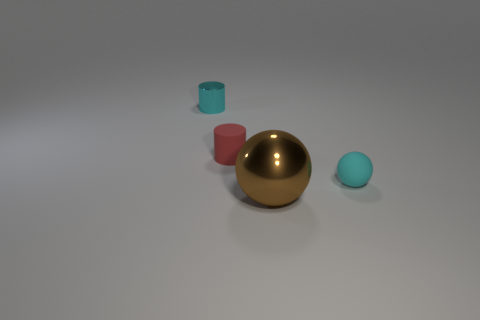There is a object that is the same color as the tiny metal cylinder; what is its material?
Offer a terse response. Rubber. Is the brown object the same size as the cyan metallic object?
Your answer should be very brief. No. There is a cyan object that is in front of the cyan object that is to the left of the rubber object to the right of the big brown metal ball; what is it made of?
Ensure brevity in your answer.  Rubber. Are there an equal number of tiny cyan balls behind the cyan sphere and brown spheres?
Ensure brevity in your answer.  No. Are there any other things that have the same size as the metal cylinder?
Your response must be concise. Yes. How many objects are big brown balls or blue things?
Your answer should be compact. 1. The other thing that is made of the same material as the tiny red thing is what shape?
Offer a terse response. Sphere. How big is the matte thing that is behind the ball behind the big brown thing?
Provide a short and direct response. Small. How many big things are either cyan metallic cylinders or shiny blocks?
Offer a terse response. 0. How many other objects are there of the same color as the small shiny object?
Offer a terse response. 1. 